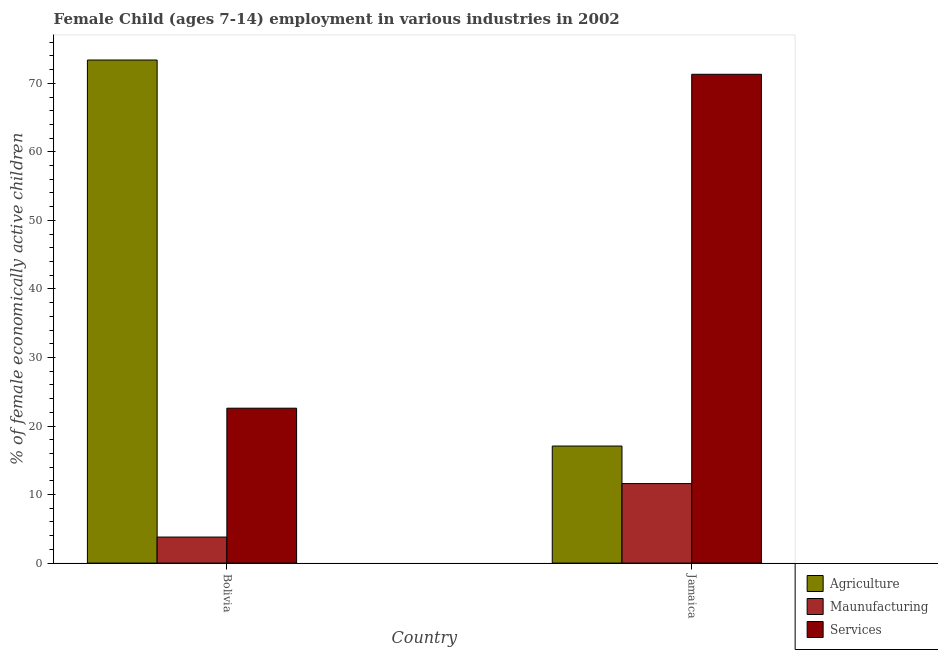Are the number of bars on each tick of the X-axis equal?
Offer a very short reply. Yes. How many bars are there on the 2nd tick from the right?
Offer a very short reply. 3. What is the label of the 1st group of bars from the left?
Keep it short and to the point. Bolivia. In how many cases, is the number of bars for a given country not equal to the number of legend labels?
Ensure brevity in your answer.  0. What is the percentage of economically active children in agriculture in Bolivia?
Offer a terse response. 73.4. Across all countries, what is the maximum percentage of economically active children in services?
Keep it short and to the point. 71.32. In which country was the percentage of economically active children in manufacturing maximum?
Make the answer very short. Jamaica. In which country was the percentage of economically active children in manufacturing minimum?
Give a very brief answer. Bolivia. What is the total percentage of economically active children in agriculture in the graph?
Offer a very short reply. 90.48. What is the difference between the percentage of economically active children in services in Bolivia and that in Jamaica?
Give a very brief answer. -48.72. What is the difference between the percentage of economically active children in manufacturing in Bolivia and the percentage of economically active children in services in Jamaica?
Offer a very short reply. -67.52. What is the average percentage of economically active children in agriculture per country?
Ensure brevity in your answer.  45.24. What is the difference between the percentage of economically active children in services and percentage of economically active children in manufacturing in Bolivia?
Provide a short and direct response. 18.8. In how many countries, is the percentage of economically active children in manufacturing greater than 18 %?
Your answer should be very brief. 0. What is the ratio of the percentage of economically active children in manufacturing in Bolivia to that in Jamaica?
Your answer should be very brief. 0.33. In how many countries, is the percentage of economically active children in agriculture greater than the average percentage of economically active children in agriculture taken over all countries?
Make the answer very short. 1. What does the 1st bar from the left in Bolivia represents?
Your answer should be very brief. Agriculture. What does the 2nd bar from the right in Jamaica represents?
Offer a terse response. Maunufacturing. Is it the case that in every country, the sum of the percentage of economically active children in agriculture and percentage of economically active children in manufacturing is greater than the percentage of economically active children in services?
Your answer should be very brief. No. How many bars are there?
Give a very brief answer. 6. Are all the bars in the graph horizontal?
Provide a short and direct response. No. How many countries are there in the graph?
Provide a succinct answer. 2. What is the difference between two consecutive major ticks on the Y-axis?
Make the answer very short. 10. Are the values on the major ticks of Y-axis written in scientific E-notation?
Give a very brief answer. No. Does the graph contain any zero values?
Make the answer very short. No. Does the graph contain grids?
Provide a short and direct response. No. Where does the legend appear in the graph?
Offer a very short reply. Bottom right. How many legend labels are there?
Provide a short and direct response. 3. How are the legend labels stacked?
Offer a very short reply. Vertical. What is the title of the graph?
Your answer should be very brief. Female Child (ages 7-14) employment in various industries in 2002. Does "Financial account" appear as one of the legend labels in the graph?
Provide a short and direct response. No. What is the label or title of the X-axis?
Offer a very short reply. Country. What is the label or title of the Y-axis?
Your response must be concise. % of female economically active children. What is the % of female economically active children of Agriculture in Bolivia?
Your response must be concise. 73.4. What is the % of female economically active children in Services in Bolivia?
Provide a succinct answer. 22.6. What is the % of female economically active children of Agriculture in Jamaica?
Ensure brevity in your answer.  17.08. What is the % of female economically active children in Services in Jamaica?
Your answer should be compact. 71.32. Across all countries, what is the maximum % of female economically active children of Agriculture?
Ensure brevity in your answer.  73.4. Across all countries, what is the maximum % of female economically active children in Maunufacturing?
Offer a terse response. 11.6. Across all countries, what is the maximum % of female economically active children of Services?
Your response must be concise. 71.32. Across all countries, what is the minimum % of female economically active children of Agriculture?
Your response must be concise. 17.08. Across all countries, what is the minimum % of female economically active children in Maunufacturing?
Your answer should be compact. 3.8. Across all countries, what is the minimum % of female economically active children in Services?
Give a very brief answer. 22.6. What is the total % of female economically active children of Agriculture in the graph?
Offer a terse response. 90.48. What is the total % of female economically active children of Services in the graph?
Your answer should be compact. 93.92. What is the difference between the % of female economically active children of Agriculture in Bolivia and that in Jamaica?
Your response must be concise. 56.32. What is the difference between the % of female economically active children of Maunufacturing in Bolivia and that in Jamaica?
Give a very brief answer. -7.8. What is the difference between the % of female economically active children of Services in Bolivia and that in Jamaica?
Keep it short and to the point. -48.72. What is the difference between the % of female economically active children in Agriculture in Bolivia and the % of female economically active children in Maunufacturing in Jamaica?
Give a very brief answer. 61.8. What is the difference between the % of female economically active children of Agriculture in Bolivia and the % of female economically active children of Services in Jamaica?
Keep it short and to the point. 2.08. What is the difference between the % of female economically active children of Maunufacturing in Bolivia and the % of female economically active children of Services in Jamaica?
Your response must be concise. -67.52. What is the average % of female economically active children in Agriculture per country?
Your answer should be compact. 45.24. What is the average % of female economically active children of Services per country?
Make the answer very short. 46.96. What is the difference between the % of female economically active children in Agriculture and % of female economically active children in Maunufacturing in Bolivia?
Your response must be concise. 69.6. What is the difference between the % of female economically active children of Agriculture and % of female economically active children of Services in Bolivia?
Provide a short and direct response. 50.8. What is the difference between the % of female economically active children of Maunufacturing and % of female economically active children of Services in Bolivia?
Give a very brief answer. -18.8. What is the difference between the % of female economically active children in Agriculture and % of female economically active children in Maunufacturing in Jamaica?
Keep it short and to the point. 5.48. What is the difference between the % of female economically active children in Agriculture and % of female economically active children in Services in Jamaica?
Provide a short and direct response. -54.24. What is the difference between the % of female economically active children in Maunufacturing and % of female economically active children in Services in Jamaica?
Make the answer very short. -59.72. What is the ratio of the % of female economically active children in Agriculture in Bolivia to that in Jamaica?
Your answer should be compact. 4.3. What is the ratio of the % of female economically active children in Maunufacturing in Bolivia to that in Jamaica?
Your answer should be very brief. 0.33. What is the ratio of the % of female economically active children of Services in Bolivia to that in Jamaica?
Keep it short and to the point. 0.32. What is the difference between the highest and the second highest % of female economically active children of Agriculture?
Your response must be concise. 56.32. What is the difference between the highest and the second highest % of female economically active children in Services?
Give a very brief answer. 48.72. What is the difference between the highest and the lowest % of female economically active children of Agriculture?
Ensure brevity in your answer.  56.32. What is the difference between the highest and the lowest % of female economically active children in Maunufacturing?
Give a very brief answer. 7.8. What is the difference between the highest and the lowest % of female economically active children of Services?
Provide a succinct answer. 48.72. 